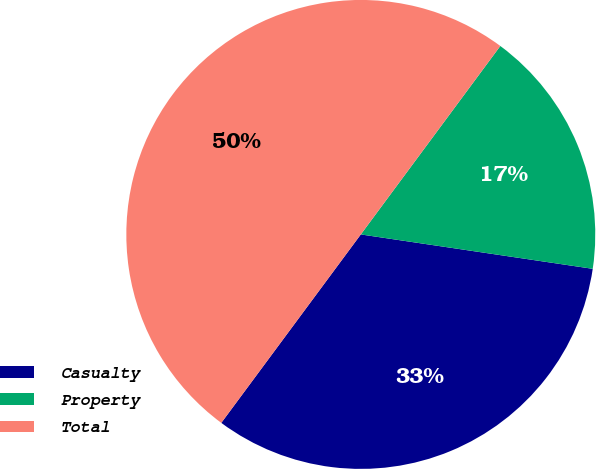Convert chart. <chart><loc_0><loc_0><loc_500><loc_500><pie_chart><fcel>Casualty<fcel>Property<fcel>Total<nl><fcel>32.8%<fcel>17.2%<fcel>50.0%<nl></chart> 